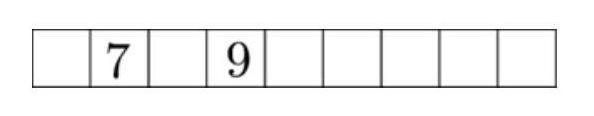The numbers from 1 to 9 are to be distributed to the nine squares in the diagram according to the following rules: There is to be one number in each square. The sum of three adjacent numbers is always a multiple of 3 . The numbers 7 and 9 are already written in. How many ways are there to insert the remaining numbers?  Answer is 24. 